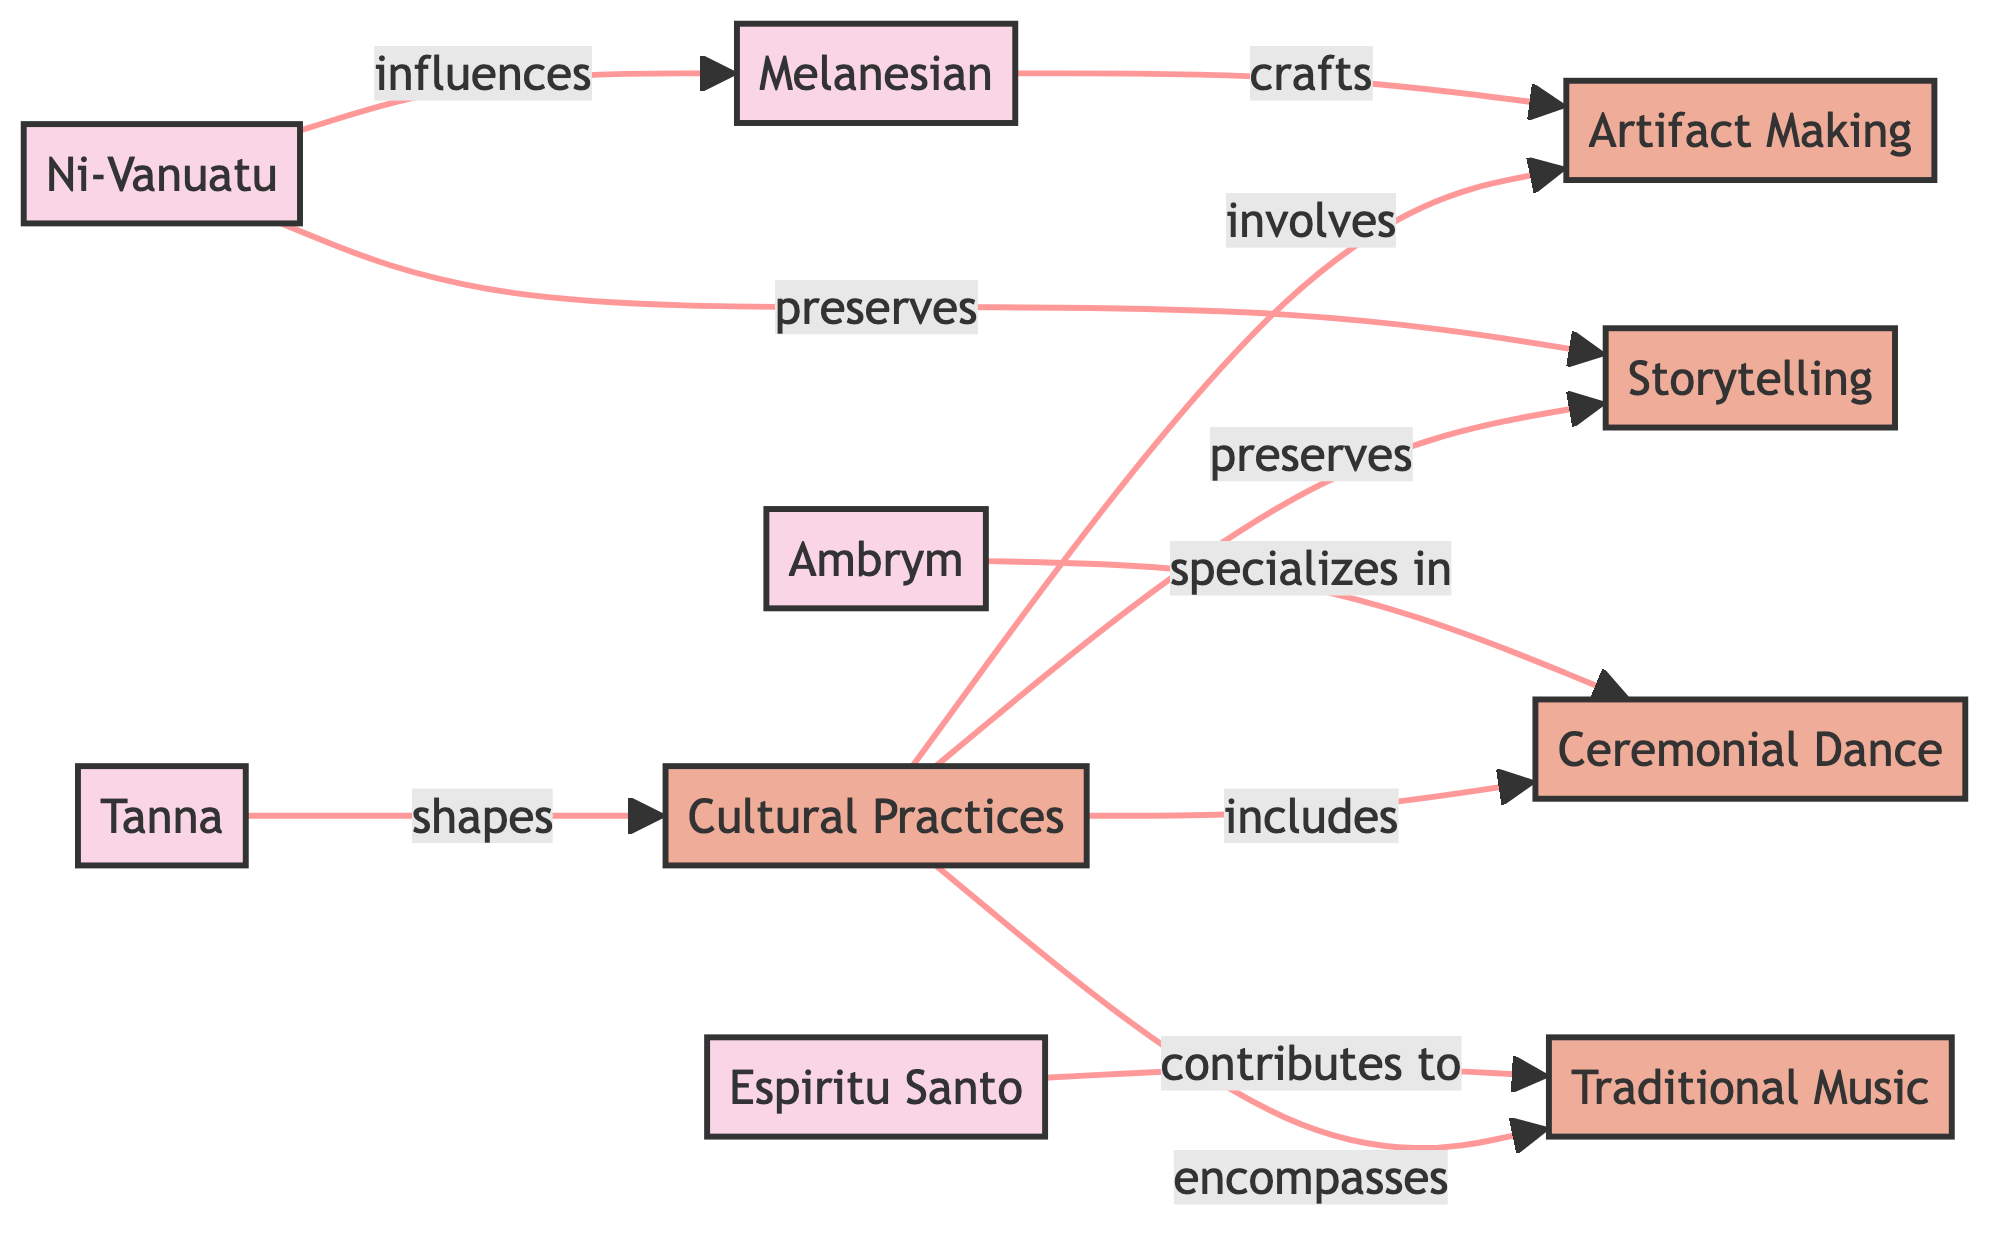What is the total number of nodes in the diagram? The diagram includes the following nodes: Ni-Vanuatu, Melanesian, Tanna, Espiritu Santo, Ambrym, Cultural Practices, Ceremonial Dance, Traditional Music, Storytelling, and Artifact Making. Counting these gives a total of 10 nodes.
Answer: 10 Which ethnic group specializes in Ceremonial Dance? The diagram shows that Ambrym has a direct relationship indicating it specializes in Ceremonial Dance. Therefore, Ambrym is the ethnic group that specializes in this practice.
Answer: Ambrym What type of cultural practice is associated with Espiritu Santo? The diagram shows that Espiritu Santo contributes to Traditional Music. This indicates the cultural practice directly linked to Espiritu Santo is Traditional Music.
Answer: Traditional Music How many edges are there connecting nodes in the diagram? The diagram lists the following edges: Ni-Vanuatu to Melanesian, Tanna to Cultural Practices, Espiritu Santo to Traditional Music, Ambrym to Ceremonial Dance, Ni-Vanuatu to Storytelling, Melanesian to Artifact Making, and several from Cultural Practices to other practices. Counting all these edges totals up to 10 edges.
Answer: 10 Which ethnic group has a relationship with Storytelling? According to the diagram, Ni-Vanuatu preserves Storytelling, which indicates a direct relationship. Therefore, the ethnic group associated with Storytelling is Ni-Vanuatu.
Answer: Ni-Vanuatu Which cultural practice is included under Cultural Practices alongside Storytelling? From the diagram, we see that Cultural Practices encompasses several practices: Ceremonial Dance, Traditional Music, Storytelling, and Artifact Making. Thus, besides Storytelling, Ceremonial Dance is also included.
Answer: Ceremonial Dance What type of connection does Melanesian have with Artifact Making? The diagram indicates that Melanesian is linked to Artifact Making through a crafting relationship. This shows that Melanesian crafts Artifact Making.
Answer: crafts Which ethnic group influences Melanesian? The diagram depicts an arrow from Ni-Vanuatu to Melanesian labeled as influences. Therefore, Ni-Vanuatu influences the Melanesian ethnic group.
Answer: Ni-Vanuatu How does Tanna relate to Cultural Practices? The diagram illustrates that Tanna shapes Cultural Practices, which indicates a defining contribution to this broader category from Tanna.
Answer: shapes 